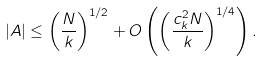<formula> <loc_0><loc_0><loc_500><loc_500>| A | \leq \left ( \frac { N } { k } \right ) ^ { 1 / 2 } + O \left ( \left ( \frac { c _ { k } ^ { 2 } N } { k } \right ) ^ { 1 / 4 } \right ) .</formula> 